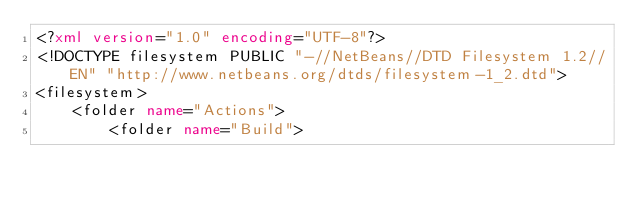<code> <loc_0><loc_0><loc_500><loc_500><_XML_><?xml version="1.0" encoding="UTF-8"?>
<!DOCTYPE filesystem PUBLIC "-//NetBeans//DTD Filesystem 1.2//EN" "http://www.netbeans.org/dtds/filesystem-1_2.dtd">
<filesystem>
    <folder name="Actions">
        <folder name="Build"></code> 